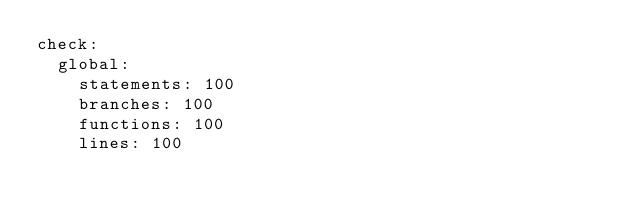Convert code to text. <code><loc_0><loc_0><loc_500><loc_500><_YAML_>check:
  global:
    statements: 100
    branches: 100
    functions: 100
    lines: 100
</code> 